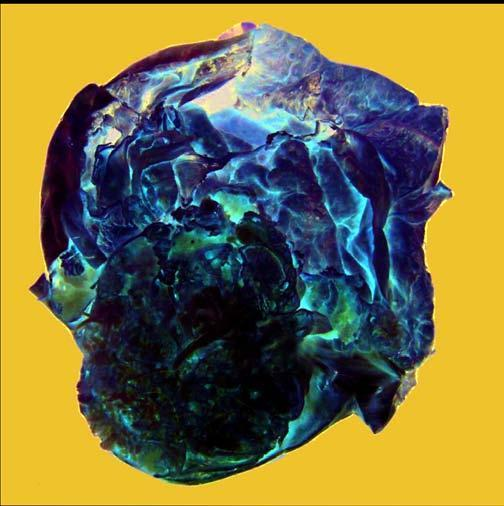does cut surface show a very large multilocular cyst without papillae?
Answer the question using a single word or phrase. Yes 